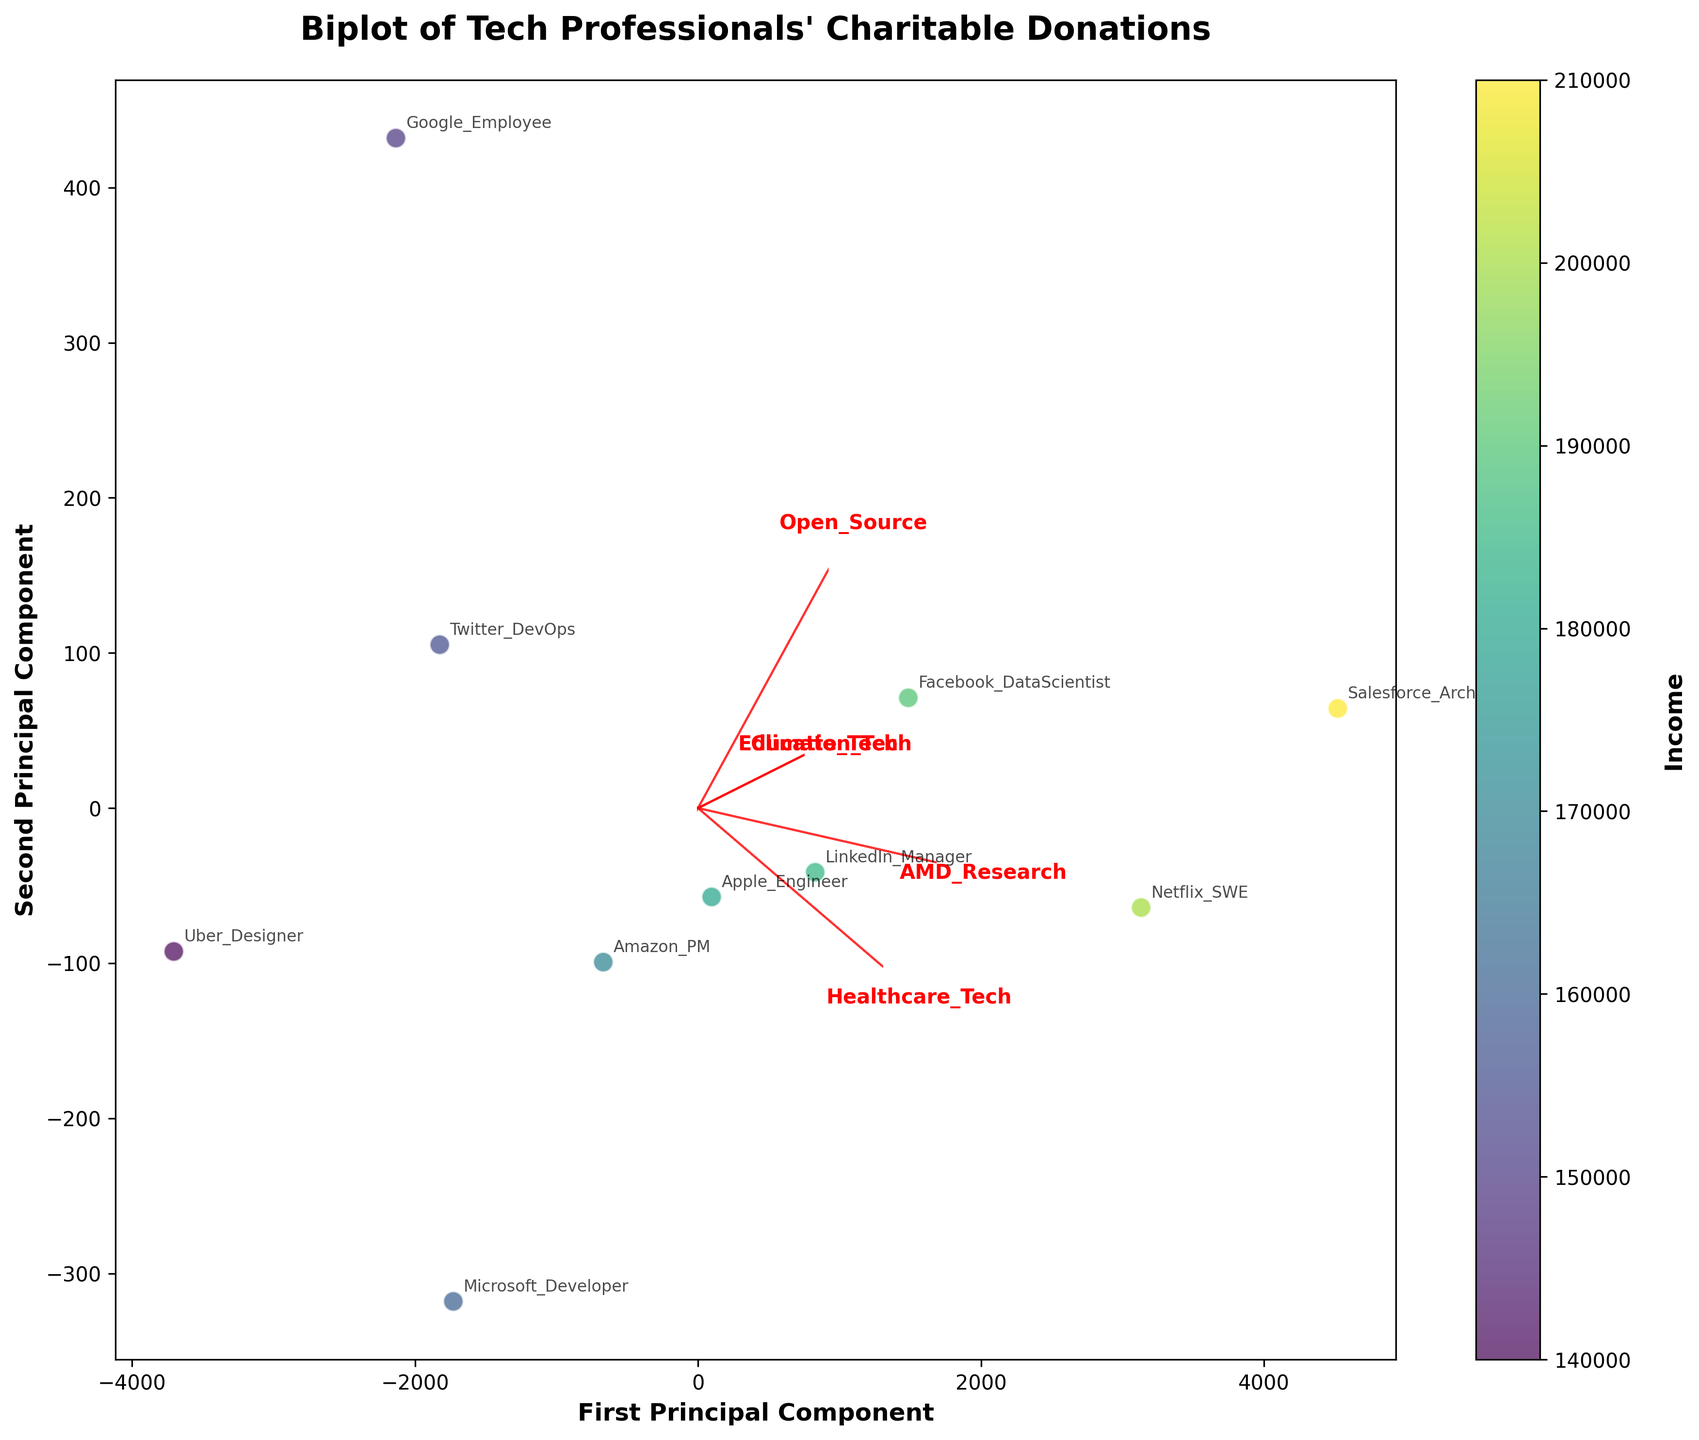What is the title of the figure? The title is typically displayed at the top of the figure. Read the text shown in that position.
Answer: "Biplot of Tech Professionals' Charitable Donations" What do the arrows represent in the plot? In a biplot, arrows typically represent the loadings of the original features on the principal components. Identify the features mentioned next to the arrows in red.
Answer: The loadings of "AMD_Research," "Healthcare_Tech," "Open_Source," "Climate_Tech," "Education_Tech" on the principal components Which data point corresponds to the highest income? Identify the data point with the highest value on the color bar, which represents income. Look for the corresponding label.
Answer: Salesforce_Architect Which feature is most positively correlated with the first principal component? Look at the arrows in the plot. The feature arrow pointing most directly to the right (first principal component) shows the highest positive correlation.
Answer: "AMD_Research" Which two employees have the closest data points in the Biplot? Compare the coordinates of the data points in the biplot, and identify the labels of the two data points closest to each other.
Answer: Apple_Engineer and Amazon_PM What is the general trend of donation amounts towards AMD research compared to other causes? Compare the lengths and directions of the arrows for various causes. The longer the arrow and more aligned with the principal component axis, the stronger the correlation and variation.
Answer: Generally higher donations towards "AMD_Research" compared to other causes Which employee has the highest PCA1 score? Identify the data point farthest to the right (positive direction) on the X-axis (first principal component) and check its label.
Answer: Salesforce_Architect How is the scattering of data points related to income levels? Observe the color gradient (income) across the scatter plot. Data points with higher income should have a different color towards one end of the scale.
Answer: Data points with higher incomes tend to have higher PCA1 values Which feature has the highest impact on the second principal component? Look at the arrows, the feature with the arrow pointing most vertically up or down (positive or negative correlation with the second principal component) indicates higher impact.
Answer: "Healthcare_Tech" Is there a visible grouping of donors based on their preferred cause? Observing the direction and positions of donor labels in relation to the arrows might show clustering based on donation preferences.
Answer: Yes, certain groupings are visible, indicating preference clustering based on causes 